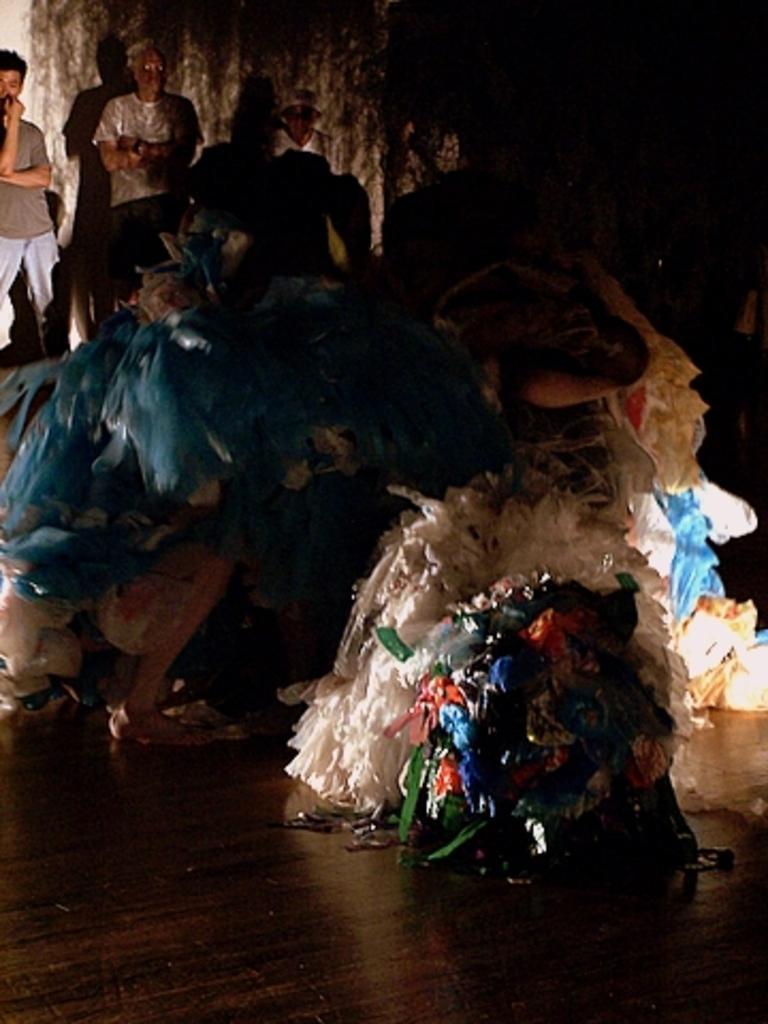Could you give a brief overview of what you see in this image? Here we can see plastic covers and this is floor. In the background there are people and this is wall. 